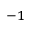Convert formula to latex. <formula><loc_0><loc_0><loc_500><loc_500>^ { - 1 }</formula> 